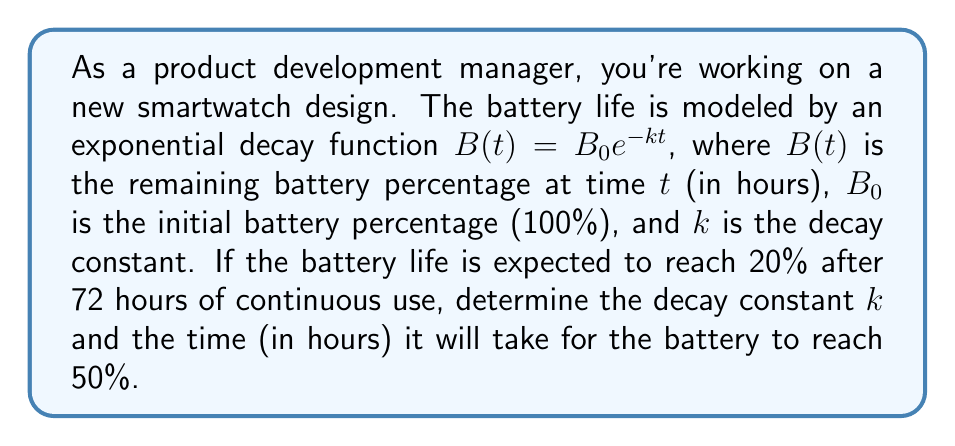Teach me how to tackle this problem. To solve this problem, we'll follow these steps:

1. Determine the decay constant $k$:
   We know that after 72 hours, the battery life is 20%. Let's use the exponential decay function:
   
   $$B(72) = 100e^{-k(72)} = 20$$
   
   Dividing both sides by 100:
   
   $$e^{-72k} = 0.2$$
   
   Taking the natural logarithm of both sides:
   
   $$-72k = \ln(0.2)$$
   
   $$k = -\frac{\ln(0.2)}{72} \approx 0.0224$$

2. Find the time when the battery reaches 50%:
   Let $t$ be the time we're looking for. We can set up the equation:
   
   $$B(t) = 100e^{-0.0224t} = 50$$
   
   Dividing both sides by 100:
   
   $$e^{-0.0224t} = 0.5$$
   
   Taking the natural logarithm of both sides:
   
   $$-0.0224t = \ln(0.5)$$
   
   $$t = -\frac{\ln(0.5)}{0.0224} \approx 30.96$$

Therefore, it will take approximately 30.96 hours for the battery to reach 50%.
Answer: The decay constant $k$ is approximately 0.0224, and it will take approximately 30.96 hours for the battery to reach 50%. 